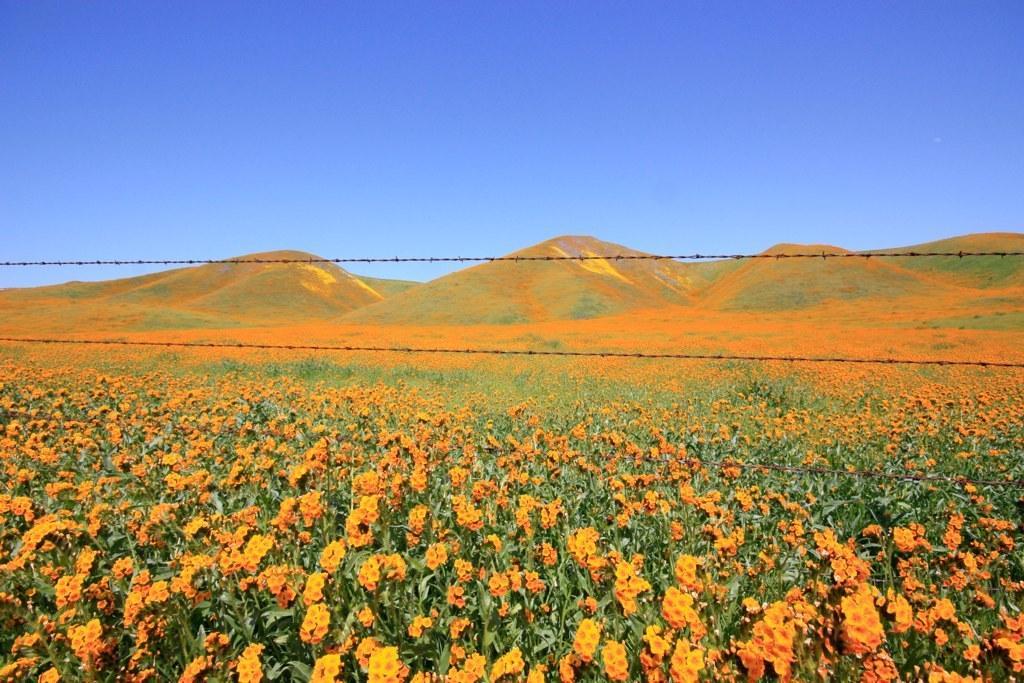Can you describe this image briefly? In this image, we can see some flowers, we can see mountains, at the top we can see the blue sky. 